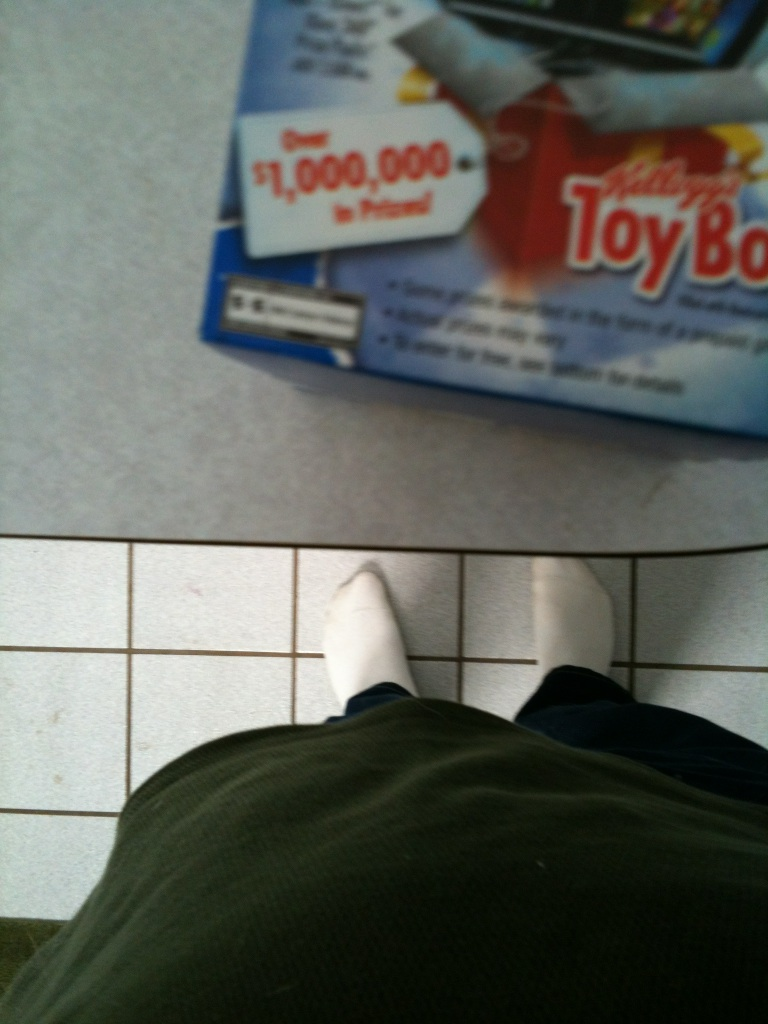Are these strawberry or smores flavor? The image does not provide clear information on whether the mentioned product is of strawberry or smores flavor. More context about the visible text or the detailed imagery on the box would be needed to accurately determine the flavor. 